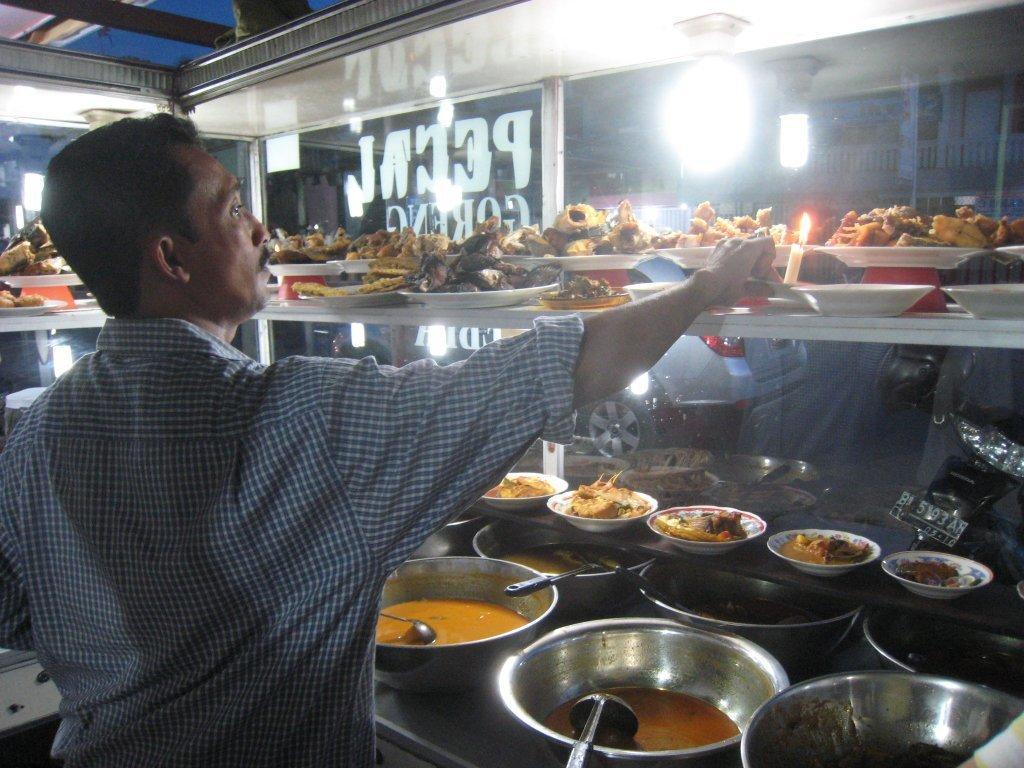Please provide a concise description of this image. In this image we can see this person is wearing a shirt and standing here. Here we can see many bowls with food item, spoons and food items kept on the plate. We can see the candle and in the background, we can see the glass on which something is written and we can see the light here. Through the glass we can see cars and bikes on the road. 